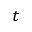<formula> <loc_0><loc_0><loc_500><loc_500>t</formula> 